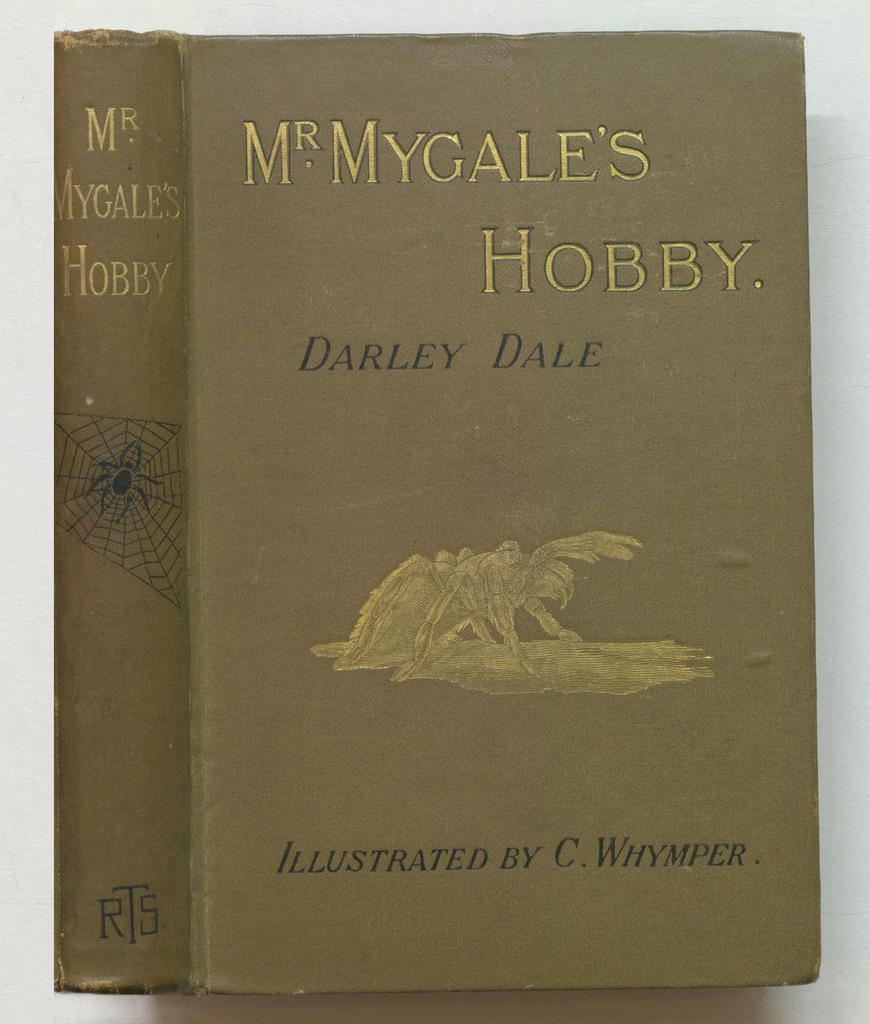<image>
Offer a succinct explanation of the picture presented. The book is called Mr. Mygale's Hobby by Darley Dale. 